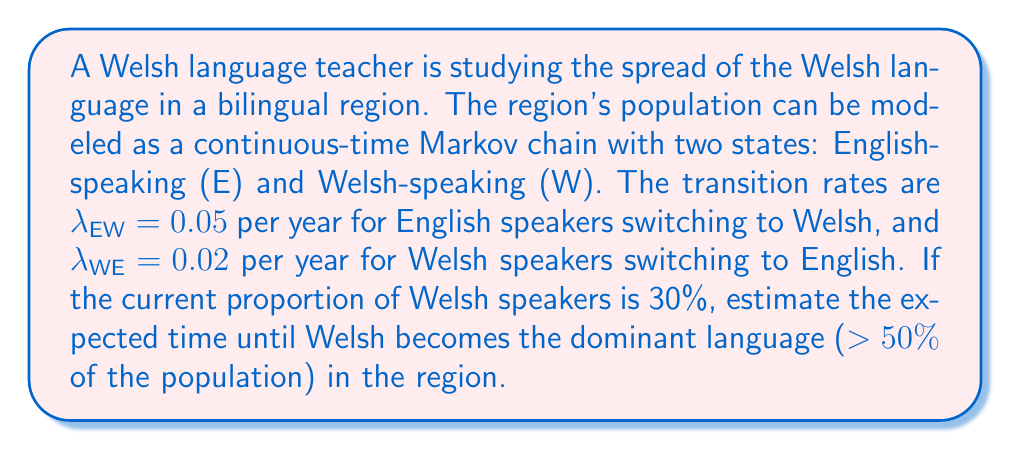Provide a solution to this math problem. To solve this problem, we'll use the properties of continuous-time Markov chains:

1) First, we need to find the steady-state distribution. Let π_E and π_W be the steady-state probabilities for English and Welsh speakers respectively. We can set up the balance equations:

   $$π_E λ_{EW} = π_W λ_{WE}$$
   $$π_E + π_W = 1$$

2) Solving these equations:

   $$π_W = \frac{λ_{EW}}{λ_{EW} + λ_{WE}} = \frac{0.05}{0.05 + 0.02} ≈ 0.7143$$

   $$π_E = 1 - π_W ≈ 0.2857$$

3) The steady-state distribution shows that Welsh will eventually become dominant.

4) To estimate the time until Welsh becomes dominant, we can use the formula for the expected hitting time. Let T be the time until the proportion of Welsh speakers reaches 50%. We need to solve:

   $$E[T] = -\frac{1}{λ_{EW} + λ_{WE}} \ln\left(\frac{π_W - 0.5}{π_W - 0.3}\right)$$

5) Substituting the values:

   $$E[T] = -\frac{1}{0.05 + 0.02} \ln\left(\frac{0.7143 - 0.5}{0.7143 - 0.3}\right)$$

6) Calculating:

   $$E[T] ≈ 14.88$$ years

Therefore, the expected time until Welsh becomes the dominant language in the region is approximately 14.88 years.
Answer: 14.88 years 